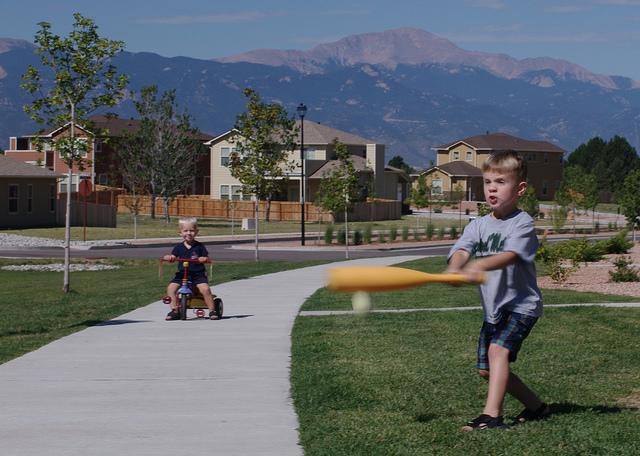What is the boy riding?
Quick response, please. Tricycle. Does the boy look happy?
Write a very short answer. Yes. Is he going to hit or miss the ball?
Answer briefly. Hit. What toy is flying through the air?
Short answer required. Ball. What game is the other boy playing?
Answer briefly. Baseball. What season does it appear to be?
Keep it brief. Summer. Where is the light pole?
Be succinct. Background. How many people in the shot?
Short answer required. 2. What are the buildings in the background?
Short answer required. Houses. 